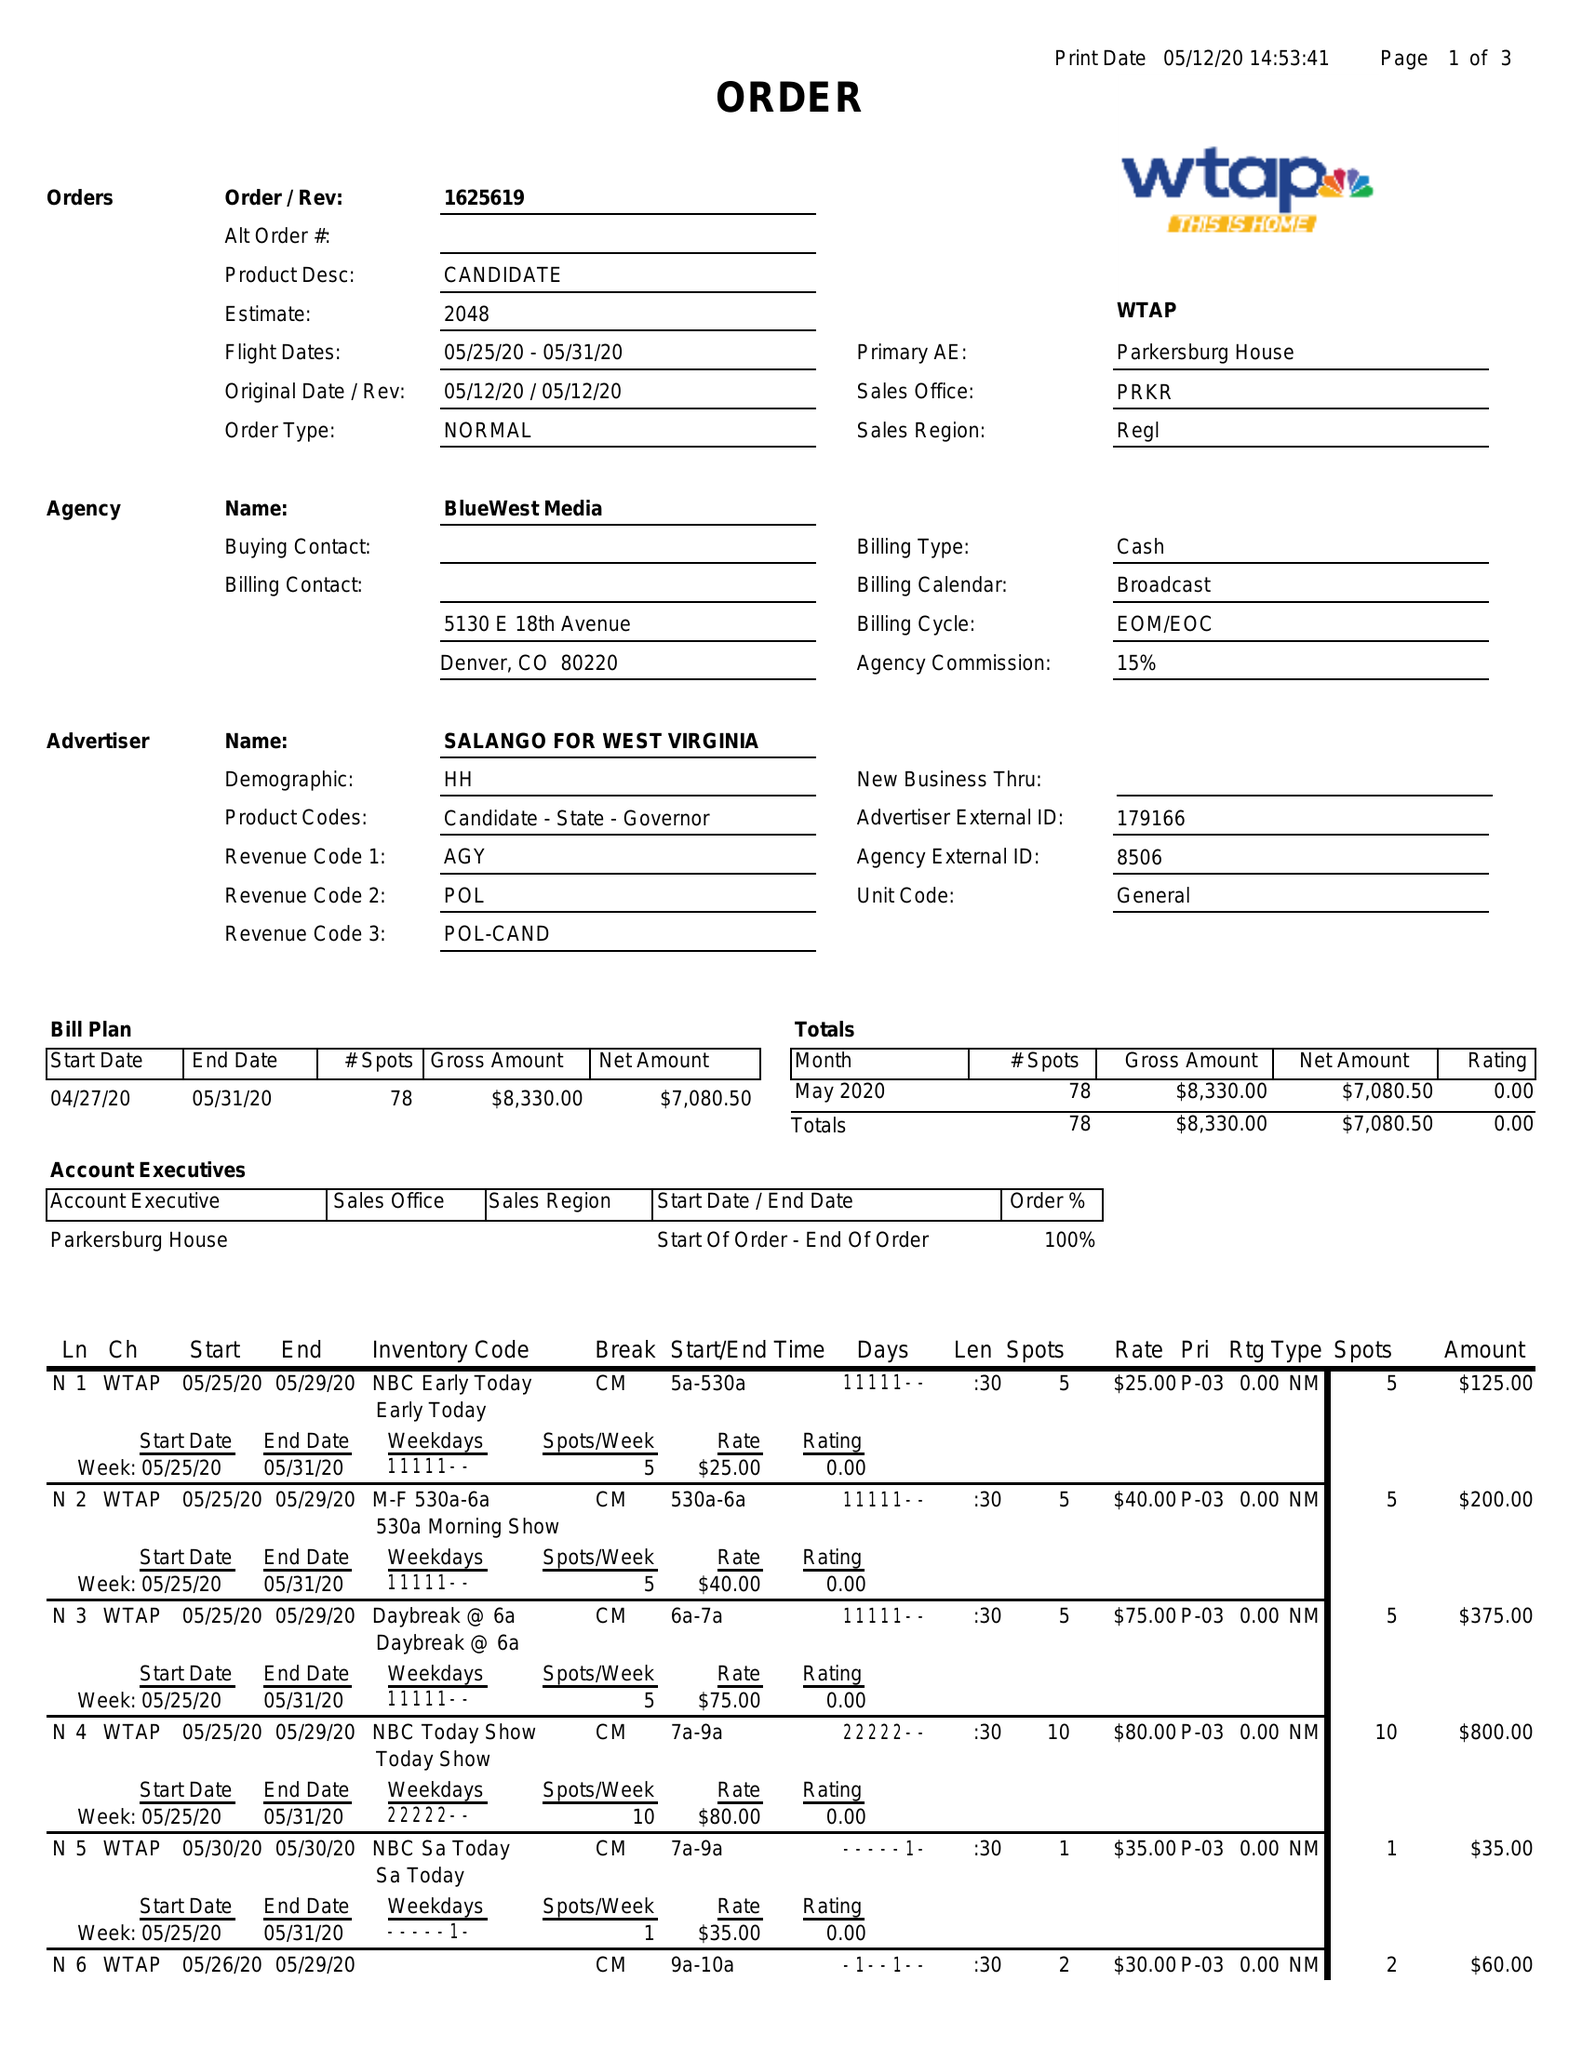What is the value for the contract_num?
Answer the question using a single word or phrase. 1625619 